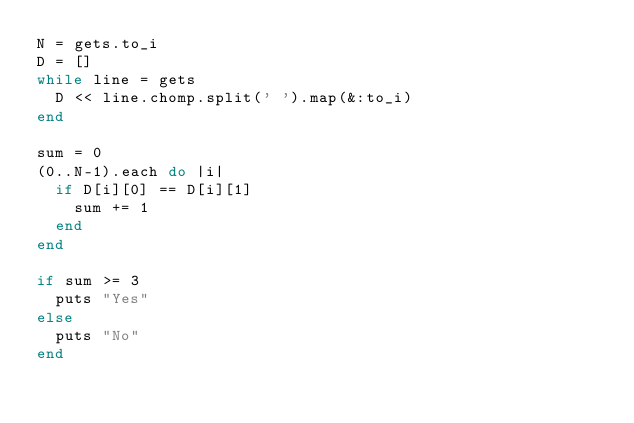<code> <loc_0><loc_0><loc_500><loc_500><_Ruby_>N = gets.to_i
D = []
while line = gets
  D << line.chomp.split(' ').map(&:to_i)
end

sum = 0
(0..N-1).each do |i|
  if D[i][0] == D[i][1]
    sum += 1
  end
end

if sum >= 3
  puts "Yes"
else
  puts "No"
end</code> 